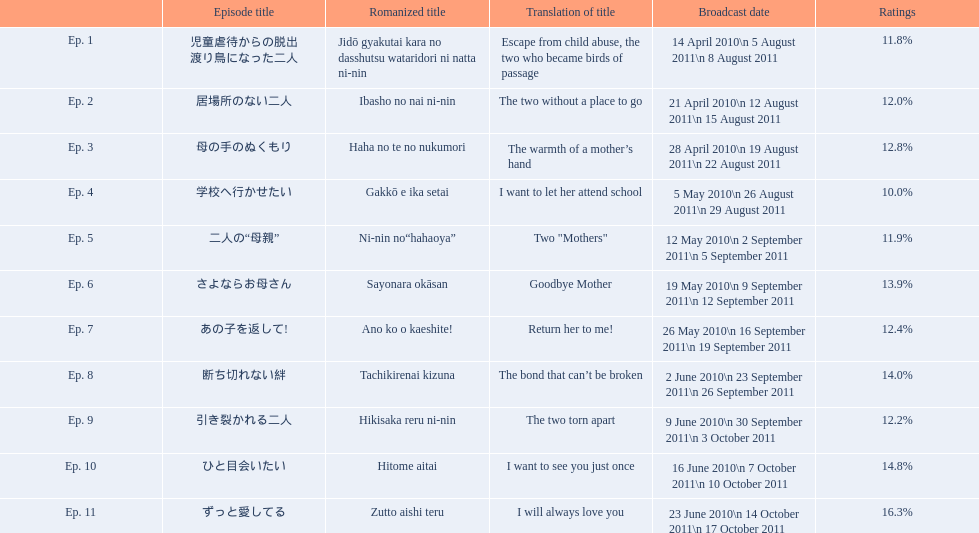Would you be able to parse every entry in this table? {'header': ['', 'Episode title', 'Romanized title', 'Translation of title', 'Broadcast date', 'Ratings'], 'rows': [['Ep. 1', '児童虐待からの脱出 渡り鳥になった二人', 'Jidō gyakutai kara no dasshutsu wataridori ni natta ni-nin', 'Escape from child abuse, the two who became birds of passage', '14 April 2010\\n 5 August 2011\\n 8 August 2011', '11.8%'], ['Ep. 2', '居場所のない二人', 'Ibasho no nai ni-nin', 'The two without a place to go', '21 April 2010\\n 12 August 2011\\n 15 August 2011', '12.0%'], ['Ep. 3', '母の手のぬくもり', 'Haha no te no nukumori', 'The warmth of a mother’s hand', '28 April 2010\\n 19 August 2011\\n 22 August 2011', '12.8%'], ['Ep. 4', '学校へ行かせたい', 'Gakkō e ika setai', 'I want to let her attend school', '5 May 2010\\n 26 August 2011\\n 29 August 2011', '10.0%'], ['Ep. 5', '二人の“母親”', 'Ni-nin no“hahaoya”', 'Two "Mothers"', '12 May 2010\\n 2 September 2011\\n 5 September 2011', '11.9%'], ['Ep. 6', 'さよならお母さん', 'Sayonara okāsan', 'Goodbye Mother', '19 May 2010\\n 9 September 2011\\n 12 September 2011', '13.9%'], ['Ep. 7', 'あの子を返して!', 'Ano ko o kaeshite!', 'Return her to me!', '26 May 2010\\n 16 September 2011\\n 19 September 2011', '12.4%'], ['Ep. 8', '断ち切れない絆', 'Tachikirenai kizuna', 'The bond that can’t be broken', '2 June 2010\\n 23 September 2011\\n 26 September 2011', '14.0%'], ['Ep. 9', '引き裂かれる二人', 'Hikisaka reru ni-nin', 'The two torn apart', '9 June 2010\\n 30 September 2011\\n 3 October 2011', '12.2%'], ['Ep. 10', 'ひと目会いたい', 'Hitome aitai', 'I want to see you just once', '16 June 2010\\n 7 October 2011\\n 10 October 2011', '14.8%'], ['Ep. 11', 'ずっと愛してる', 'Zutto aishi teru', 'I will always love you', '23 June 2010\\n 14 October 2011\\n 17 October 2011', '16.3%']]} What was the appellation of the installment succeeding goodbye mother? あの子を返して!. 